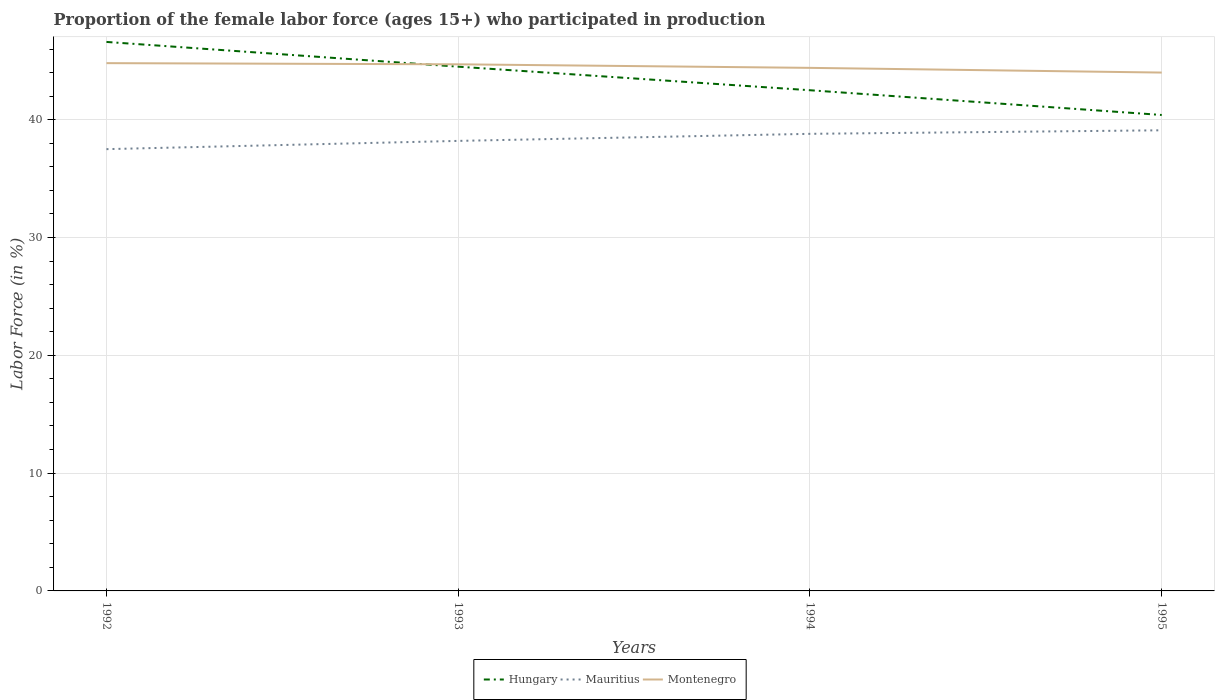How many different coloured lines are there?
Give a very brief answer. 3. Across all years, what is the maximum proportion of the female labor force who participated in production in Hungary?
Keep it short and to the point. 40.4. In which year was the proportion of the female labor force who participated in production in Hungary maximum?
Offer a terse response. 1995. What is the total proportion of the female labor force who participated in production in Mauritius in the graph?
Make the answer very short. -0.9. What is the difference between the highest and the second highest proportion of the female labor force who participated in production in Mauritius?
Offer a very short reply. 1.6. Is the proportion of the female labor force who participated in production in Hungary strictly greater than the proportion of the female labor force who participated in production in Montenegro over the years?
Ensure brevity in your answer.  No. How many years are there in the graph?
Give a very brief answer. 4. Does the graph contain any zero values?
Make the answer very short. No. How many legend labels are there?
Make the answer very short. 3. How are the legend labels stacked?
Provide a succinct answer. Horizontal. What is the title of the graph?
Your answer should be very brief. Proportion of the female labor force (ages 15+) who participated in production. What is the Labor Force (in %) in Hungary in 1992?
Your answer should be very brief. 46.6. What is the Labor Force (in %) in Mauritius in 1992?
Provide a short and direct response. 37.5. What is the Labor Force (in %) of Montenegro in 1992?
Make the answer very short. 44.8. What is the Labor Force (in %) in Hungary in 1993?
Ensure brevity in your answer.  44.5. What is the Labor Force (in %) in Mauritius in 1993?
Provide a short and direct response. 38.2. What is the Labor Force (in %) of Montenegro in 1993?
Make the answer very short. 44.7. What is the Labor Force (in %) in Hungary in 1994?
Provide a succinct answer. 42.5. What is the Labor Force (in %) in Mauritius in 1994?
Offer a terse response. 38.8. What is the Labor Force (in %) in Montenegro in 1994?
Offer a terse response. 44.4. What is the Labor Force (in %) of Hungary in 1995?
Offer a terse response. 40.4. What is the Labor Force (in %) in Mauritius in 1995?
Ensure brevity in your answer.  39.1. What is the Labor Force (in %) in Montenegro in 1995?
Give a very brief answer. 44. Across all years, what is the maximum Labor Force (in %) in Hungary?
Offer a very short reply. 46.6. Across all years, what is the maximum Labor Force (in %) of Mauritius?
Offer a terse response. 39.1. Across all years, what is the maximum Labor Force (in %) of Montenegro?
Offer a very short reply. 44.8. Across all years, what is the minimum Labor Force (in %) in Hungary?
Provide a short and direct response. 40.4. Across all years, what is the minimum Labor Force (in %) in Mauritius?
Offer a very short reply. 37.5. What is the total Labor Force (in %) in Hungary in the graph?
Give a very brief answer. 174. What is the total Labor Force (in %) in Mauritius in the graph?
Ensure brevity in your answer.  153.6. What is the total Labor Force (in %) in Montenegro in the graph?
Ensure brevity in your answer.  177.9. What is the difference between the Labor Force (in %) in Hungary in 1992 and that in 1993?
Ensure brevity in your answer.  2.1. What is the difference between the Labor Force (in %) of Mauritius in 1992 and that in 1993?
Ensure brevity in your answer.  -0.7. What is the difference between the Labor Force (in %) of Montenegro in 1992 and that in 1993?
Offer a terse response. 0.1. What is the difference between the Labor Force (in %) of Hungary in 1992 and that in 1994?
Provide a succinct answer. 4.1. What is the difference between the Labor Force (in %) in Hungary in 1992 and that in 1995?
Provide a succinct answer. 6.2. What is the difference between the Labor Force (in %) in Hungary in 1994 and that in 1995?
Provide a short and direct response. 2.1. What is the difference between the Labor Force (in %) of Hungary in 1992 and the Labor Force (in %) of Mauritius in 1993?
Make the answer very short. 8.4. What is the difference between the Labor Force (in %) of Hungary in 1992 and the Labor Force (in %) of Montenegro in 1993?
Provide a succinct answer. 1.9. What is the difference between the Labor Force (in %) in Hungary in 1992 and the Labor Force (in %) in Mauritius in 1994?
Offer a terse response. 7.8. What is the difference between the Labor Force (in %) of Hungary in 1992 and the Labor Force (in %) of Montenegro in 1994?
Give a very brief answer. 2.2. What is the difference between the Labor Force (in %) of Hungary in 1992 and the Labor Force (in %) of Mauritius in 1995?
Provide a short and direct response. 7.5. What is the difference between the Labor Force (in %) of Hungary in 1992 and the Labor Force (in %) of Montenegro in 1995?
Your answer should be very brief. 2.6. What is the difference between the Labor Force (in %) in Mauritius in 1992 and the Labor Force (in %) in Montenegro in 1995?
Offer a very short reply. -6.5. What is the difference between the Labor Force (in %) of Hungary in 1993 and the Labor Force (in %) of Mauritius in 1994?
Make the answer very short. 5.7. What is the difference between the Labor Force (in %) in Mauritius in 1993 and the Labor Force (in %) in Montenegro in 1994?
Give a very brief answer. -6.2. What is the difference between the Labor Force (in %) of Hungary in 1993 and the Labor Force (in %) of Mauritius in 1995?
Keep it short and to the point. 5.4. What is the difference between the Labor Force (in %) of Hungary in 1994 and the Labor Force (in %) of Montenegro in 1995?
Provide a succinct answer. -1.5. What is the average Labor Force (in %) of Hungary per year?
Offer a very short reply. 43.5. What is the average Labor Force (in %) in Mauritius per year?
Provide a succinct answer. 38.4. What is the average Labor Force (in %) in Montenegro per year?
Give a very brief answer. 44.48. In the year 1992, what is the difference between the Labor Force (in %) of Mauritius and Labor Force (in %) of Montenegro?
Your answer should be compact. -7.3. In the year 1993, what is the difference between the Labor Force (in %) of Hungary and Labor Force (in %) of Mauritius?
Keep it short and to the point. 6.3. In the year 1993, what is the difference between the Labor Force (in %) in Hungary and Labor Force (in %) in Montenegro?
Your response must be concise. -0.2. In the year 1993, what is the difference between the Labor Force (in %) in Mauritius and Labor Force (in %) in Montenegro?
Give a very brief answer. -6.5. In the year 1994, what is the difference between the Labor Force (in %) of Hungary and Labor Force (in %) of Montenegro?
Offer a very short reply. -1.9. In the year 1994, what is the difference between the Labor Force (in %) in Mauritius and Labor Force (in %) in Montenegro?
Provide a succinct answer. -5.6. What is the ratio of the Labor Force (in %) in Hungary in 1992 to that in 1993?
Make the answer very short. 1.05. What is the ratio of the Labor Force (in %) in Mauritius in 1992 to that in 1993?
Offer a terse response. 0.98. What is the ratio of the Labor Force (in %) in Montenegro in 1992 to that in 1993?
Offer a terse response. 1. What is the ratio of the Labor Force (in %) of Hungary in 1992 to that in 1994?
Your answer should be very brief. 1.1. What is the ratio of the Labor Force (in %) in Mauritius in 1992 to that in 1994?
Your answer should be compact. 0.97. What is the ratio of the Labor Force (in %) in Montenegro in 1992 to that in 1994?
Ensure brevity in your answer.  1.01. What is the ratio of the Labor Force (in %) in Hungary in 1992 to that in 1995?
Keep it short and to the point. 1.15. What is the ratio of the Labor Force (in %) in Mauritius in 1992 to that in 1995?
Your response must be concise. 0.96. What is the ratio of the Labor Force (in %) of Montenegro in 1992 to that in 1995?
Offer a terse response. 1.02. What is the ratio of the Labor Force (in %) of Hungary in 1993 to that in 1994?
Keep it short and to the point. 1.05. What is the ratio of the Labor Force (in %) of Mauritius in 1993 to that in 1994?
Keep it short and to the point. 0.98. What is the ratio of the Labor Force (in %) in Montenegro in 1993 to that in 1994?
Provide a succinct answer. 1.01. What is the ratio of the Labor Force (in %) in Hungary in 1993 to that in 1995?
Your answer should be very brief. 1.1. What is the ratio of the Labor Force (in %) in Montenegro in 1993 to that in 1995?
Provide a short and direct response. 1.02. What is the ratio of the Labor Force (in %) in Hungary in 1994 to that in 1995?
Offer a very short reply. 1.05. What is the ratio of the Labor Force (in %) of Montenegro in 1994 to that in 1995?
Make the answer very short. 1.01. What is the difference between the highest and the second highest Labor Force (in %) of Hungary?
Provide a short and direct response. 2.1. What is the difference between the highest and the second highest Labor Force (in %) of Mauritius?
Your answer should be compact. 0.3. What is the difference between the highest and the second highest Labor Force (in %) in Montenegro?
Your answer should be compact. 0.1. 